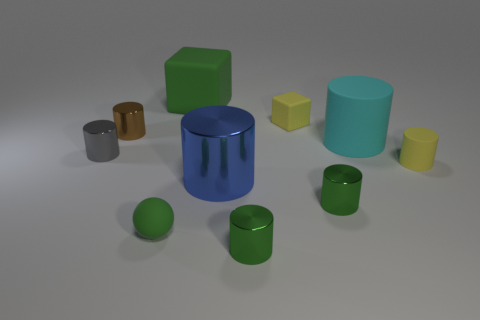Subtract all tiny matte cylinders. How many cylinders are left? 6 Subtract all blue cylinders. How many cylinders are left? 6 Subtract all brown balls. How many green cylinders are left? 2 Subtract all spheres. How many objects are left? 9 Subtract 3 cylinders. How many cylinders are left? 4 Add 6 small green matte objects. How many small green matte objects are left? 7 Add 2 blue cylinders. How many blue cylinders exist? 3 Subtract 0 yellow spheres. How many objects are left? 10 Subtract all green cylinders. Subtract all cyan spheres. How many cylinders are left? 5 Subtract all big brown blocks. Subtract all tiny yellow cylinders. How many objects are left? 9 